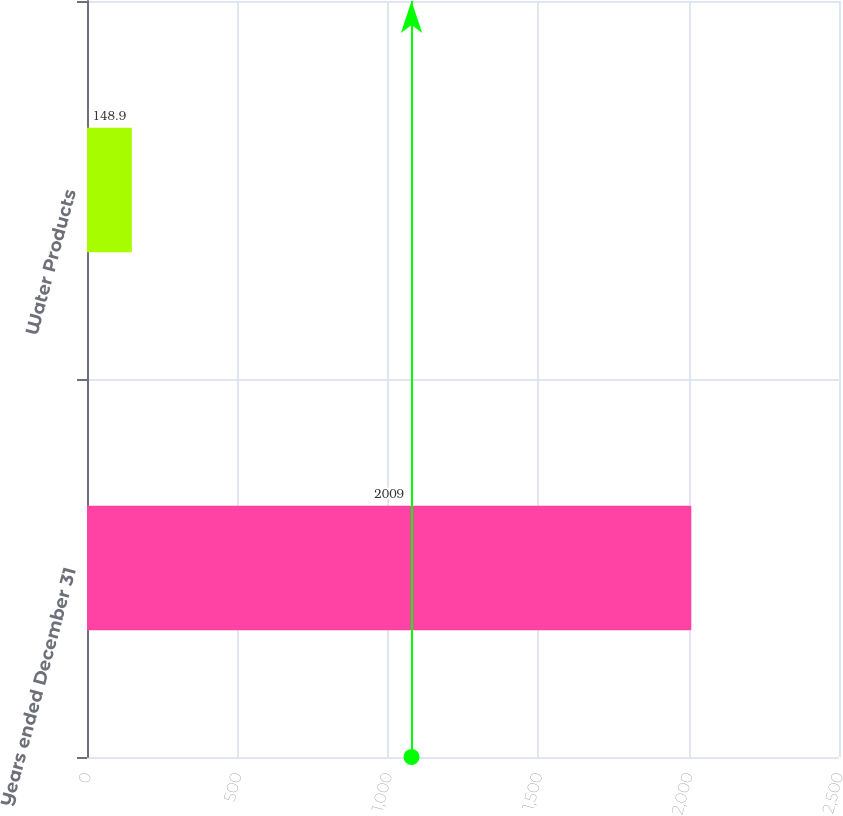Convert chart. <chart><loc_0><loc_0><loc_500><loc_500><bar_chart><fcel>Years ended December 31<fcel>Water Products<nl><fcel>2009<fcel>148.9<nl></chart> 